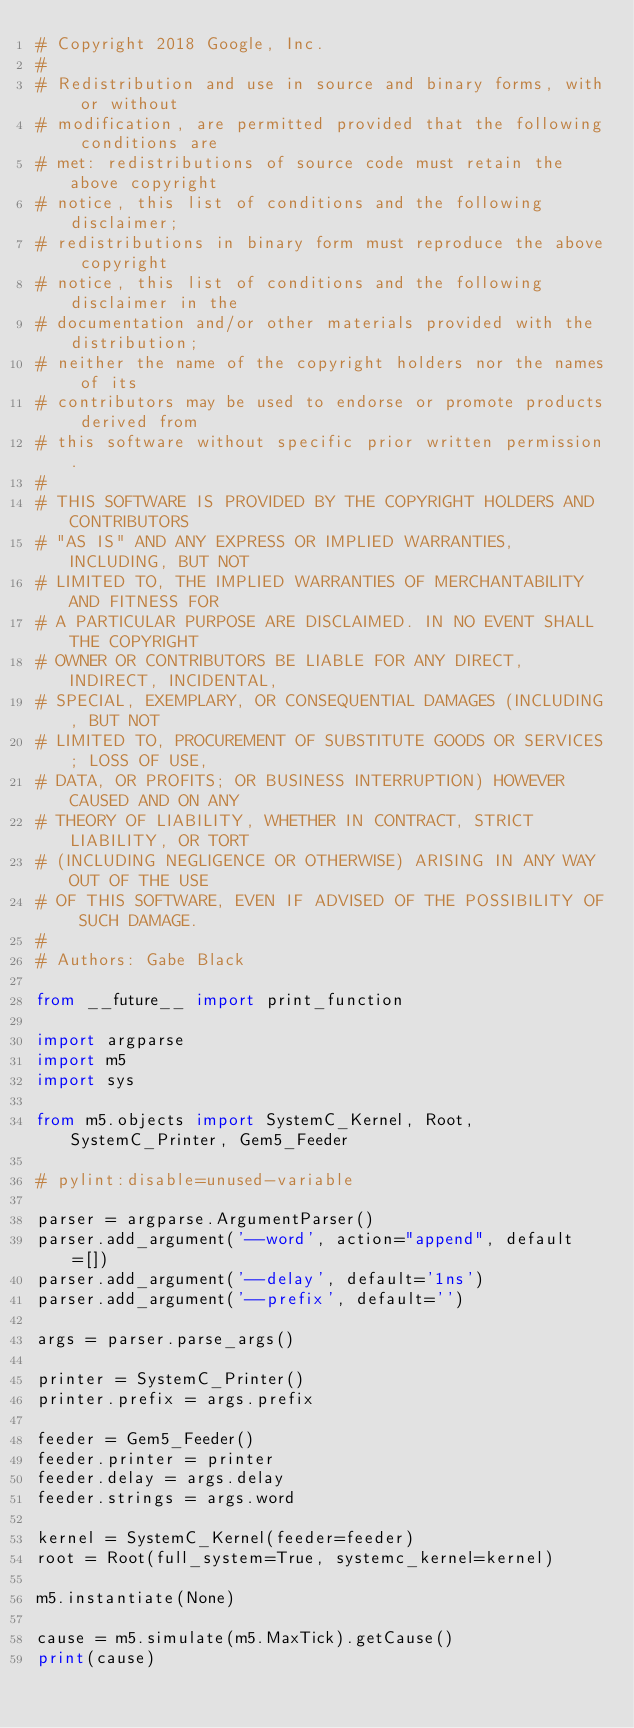Convert code to text. <code><loc_0><loc_0><loc_500><loc_500><_Python_># Copyright 2018 Google, Inc.
#
# Redistribution and use in source and binary forms, with or without
# modification, are permitted provided that the following conditions are
# met: redistributions of source code must retain the above copyright
# notice, this list of conditions and the following disclaimer;
# redistributions in binary form must reproduce the above copyright
# notice, this list of conditions and the following disclaimer in the
# documentation and/or other materials provided with the distribution;
# neither the name of the copyright holders nor the names of its
# contributors may be used to endorse or promote products derived from
# this software without specific prior written permission.
#
# THIS SOFTWARE IS PROVIDED BY THE COPYRIGHT HOLDERS AND CONTRIBUTORS
# "AS IS" AND ANY EXPRESS OR IMPLIED WARRANTIES, INCLUDING, BUT NOT
# LIMITED TO, THE IMPLIED WARRANTIES OF MERCHANTABILITY AND FITNESS FOR
# A PARTICULAR PURPOSE ARE DISCLAIMED. IN NO EVENT SHALL THE COPYRIGHT
# OWNER OR CONTRIBUTORS BE LIABLE FOR ANY DIRECT, INDIRECT, INCIDENTAL,
# SPECIAL, EXEMPLARY, OR CONSEQUENTIAL DAMAGES (INCLUDING, BUT NOT
# LIMITED TO, PROCUREMENT OF SUBSTITUTE GOODS OR SERVICES; LOSS OF USE,
# DATA, OR PROFITS; OR BUSINESS INTERRUPTION) HOWEVER CAUSED AND ON ANY
# THEORY OF LIABILITY, WHETHER IN CONTRACT, STRICT LIABILITY, OR TORT
# (INCLUDING NEGLIGENCE OR OTHERWISE) ARISING IN ANY WAY OUT OF THE USE
# OF THIS SOFTWARE, EVEN IF ADVISED OF THE POSSIBILITY OF SUCH DAMAGE.
#
# Authors: Gabe Black

from __future__ import print_function

import argparse
import m5
import sys

from m5.objects import SystemC_Kernel, Root, SystemC_Printer, Gem5_Feeder

# pylint:disable=unused-variable

parser = argparse.ArgumentParser()
parser.add_argument('--word', action="append", default=[])
parser.add_argument('--delay', default='1ns')
parser.add_argument('--prefix', default='')

args = parser.parse_args()

printer = SystemC_Printer()
printer.prefix = args.prefix

feeder = Gem5_Feeder()
feeder.printer = printer
feeder.delay = args.delay
feeder.strings = args.word

kernel = SystemC_Kernel(feeder=feeder)
root = Root(full_system=True, systemc_kernel=kernel)

m5.instantiate(None)

cause = m5.simulate(m5.MaxTick).getCause()
print(cause)
</code> 